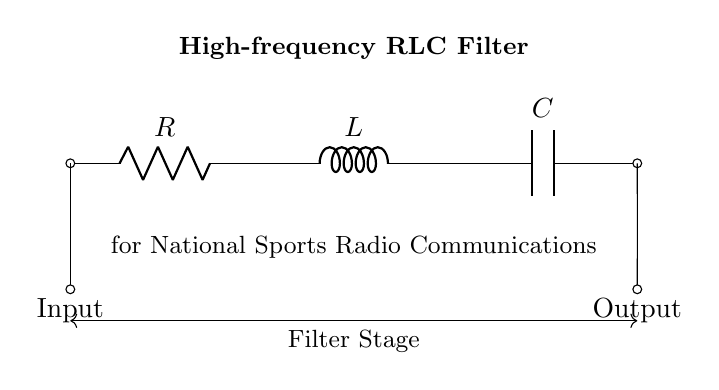What is the function of the resistor in this circuit? The resistor limits the current flow and helps to determine the overall impedance of the filter. Its presence is crucial for controlling the voltage drop across the circuit.
Answer: Current limitation What are the components used in the circuit? The components are a resistor, an inductor, and a capacitor, arranged in series for creating a high-frequency filter. These elements work together to filter specific frequency signals.
Answer: Resistor, inductor, capacitor What type of filter does this circuit represent? This circuit represents a high-frequency RLC filter, which is designed to allow high-frequency signals to pass while attenuating low-frequency signals.
Answer: High-frequency filter How are the components connected in this circuit? The components are connected in series, meaning the current flows through the resistor first, then the inductor, and finally the capacitor in a single path. This series arrangement is key for the filter's operation.
Answer: In series What is the purpose of the capacitor in the circuit? The capacitor stores energy in the electric field and contributes to the filtering effect by blocking low-frequency signals while allowing high-frequency signals to pass through to the output.
Answer: Energy storage What determines the cutoff frequency of this RLC filter? The cutoff frequency is primarily determined by the values of the resistor, inductor, and capacitor, specifically using the formula which relates these components in the context of the filter circuit.
Answer: Resistor, inductor, capacitor values 